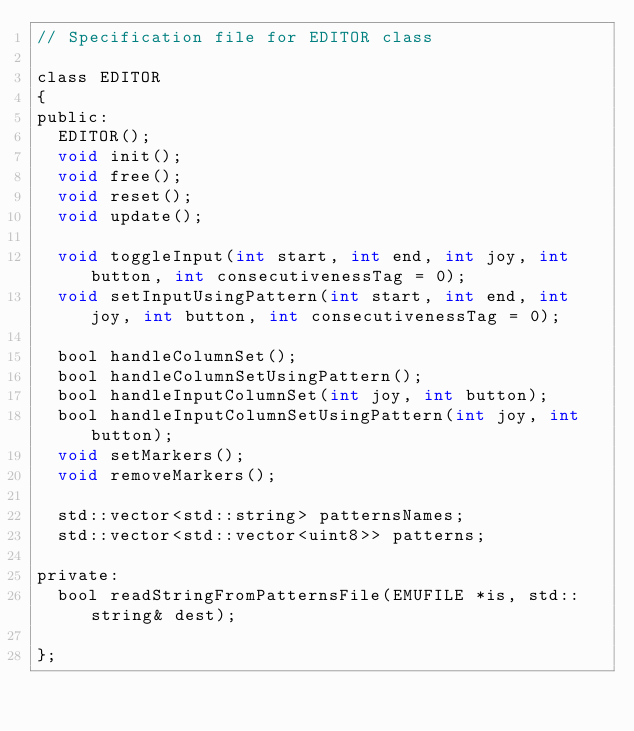<code> <loc_0><loc_0><loc_500><loc_500><_C_>// Specification file for EDITOR class

class EDITOR
{
public:
	EDITOR();
	void init();
	void free();
	void reset();
	void update();

	void toggleInput(int start, int end, int joy, int button, int consecutivenessTag = 0);
	void setInputUsingPattern(int start, int end, int joy, int button, int consecutivenessTag = 0);

	bool handleColumnSet();
	bool handleColumnSetUsingPattern();
	bool handleInputColumnSet(int joy, int button);
	bool handleInputColumnSetUsingPattern(int joy, int button);
	void setMarkers();
	void removeMarkers();

	std::vector<std::string> patternsNames;
	std::vector<std::vector<uint8>> patterns;

private:
	bool readStringFromPatternsFile(EMUFILE *is, std::string& dest);

};
</code> 